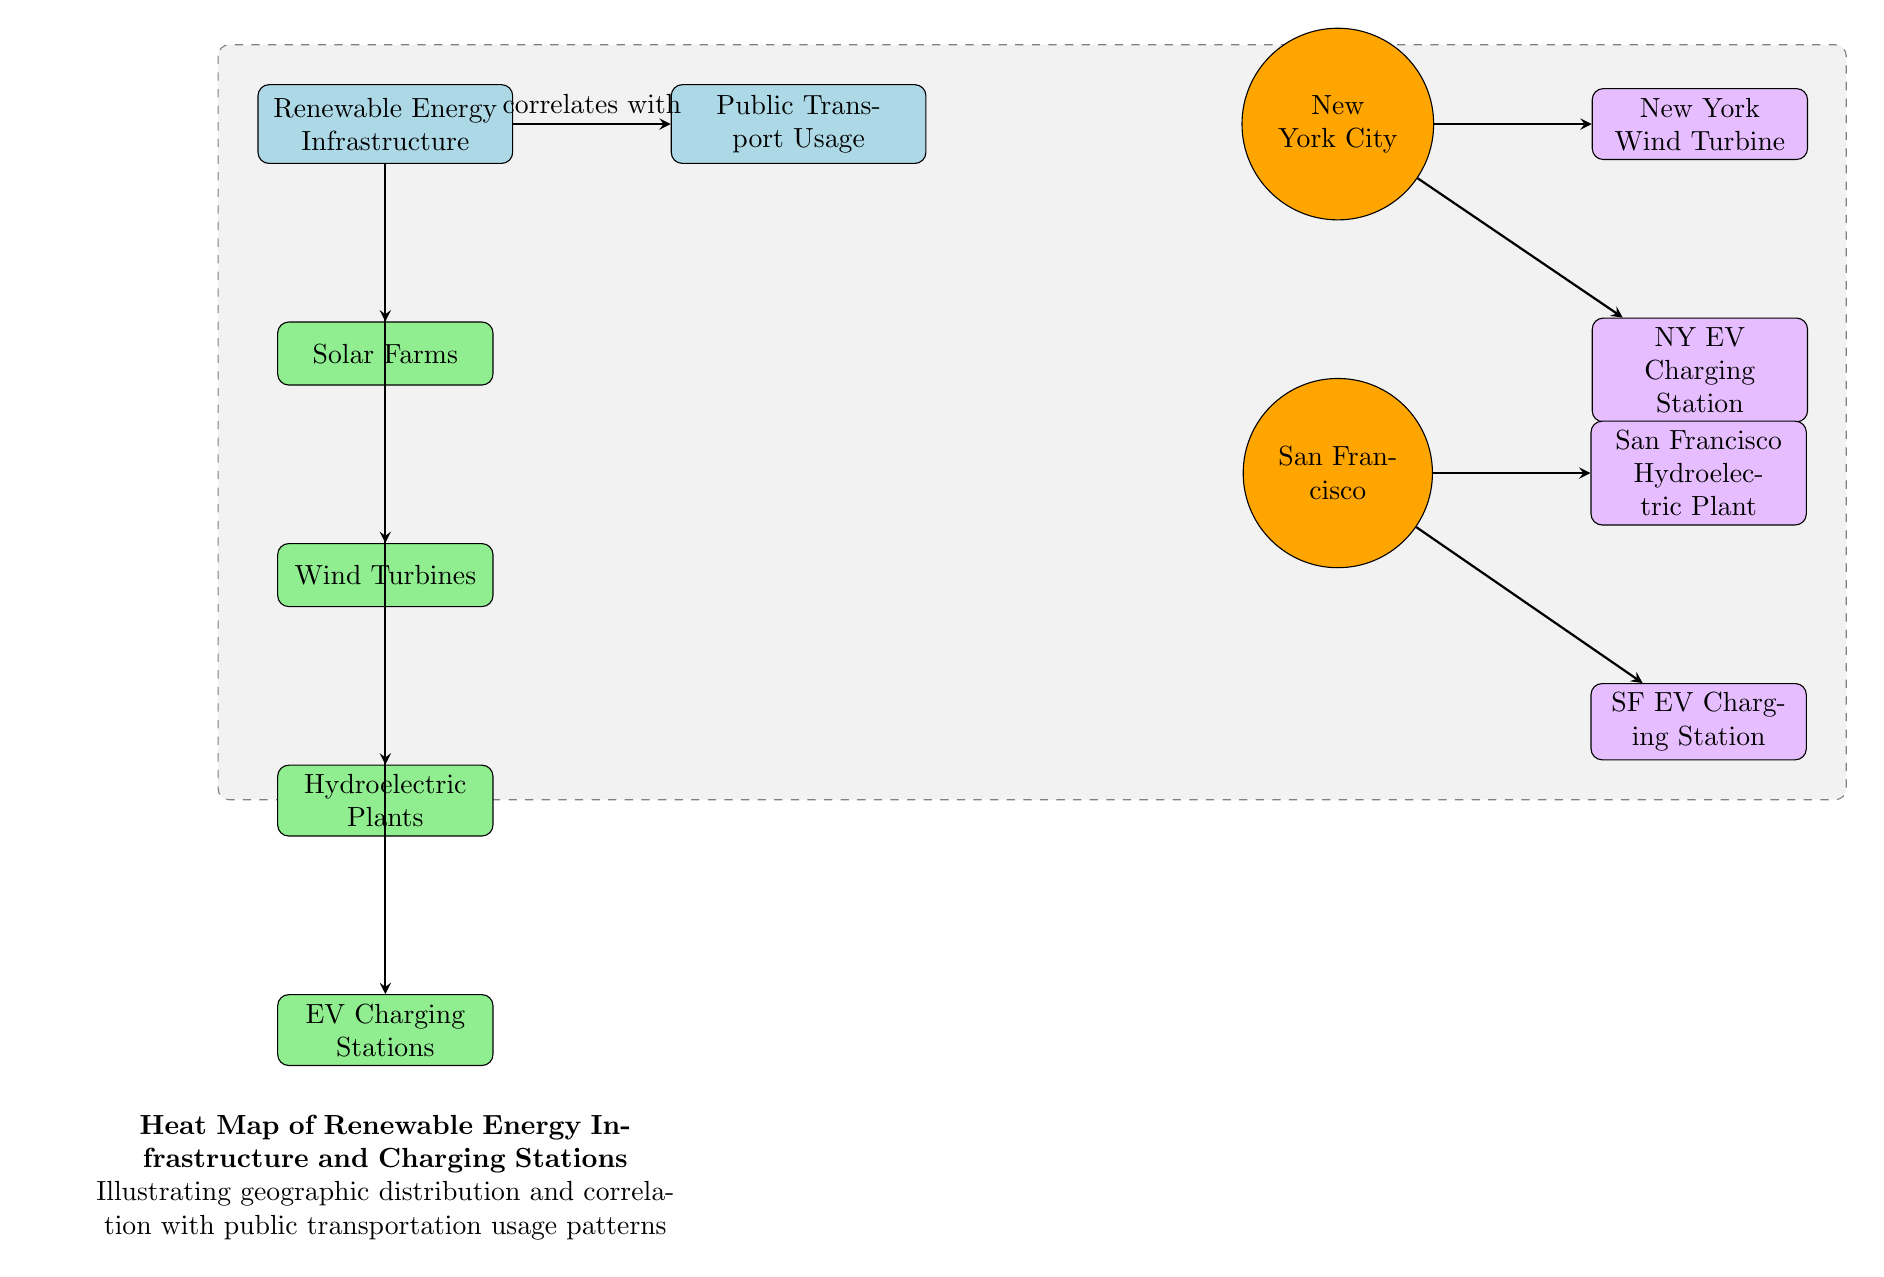What are the types of renewable energy infrastructure included in the diagram? The diagram displays the following renewable energy infrastructure types: Solar Farms, Wind Turbines, Hydroelectric Plants, and EV Charging Stations. This information is found in the subcategories below the "Renewable Energy Infrastructure" category in the diagram.
Answer: Solar Farms, Wind Turbines, Hydroelectric Plants, EV Charging Stations How many regions are represented in the diagram? The diagram features two regions: New York City and San Francisco. These regions are labeled as circular nodes and are placed to the right of the "Public Transport Usage" category. Counting these nodes gives the number of regions.
Answer: 2 Which infrastructure is associated with New York City? New York City is associated with two infrastructures: New York Wind Turbine and NY EV Charging Station. The arrows connecting these infrastructures to the New York City region indicate this direct association in the diagram.
Answer: New York Wind Turbine, NY EV Charging Station Which renewable energy infrastructure is located in San Francisco? In San Francisco, the infrastructure identified includes the San Francisco Hydroelectric Plant and SF EV Charging Station, illustrated by the direct arrows connecting these infrastructures to the San Francisco region in the diagram.
Answer: San Francisco Hydroelectric Plant, SF EV Charging Station What is the main correlation indicated in the diagram? The main correlation indicated in the diagram is that renewable energy infrastructure correlates with public transport usage. This relationship is represented by the arrow that directly connects the "Renewable Energy Infrastructure" category to the "Public Transport Usage" category.
Answer: Correlates with What is the color used for public transport usage in the diagram? The color used for the public transport usage category in the diagram is light blue. This can be confirmed by observing the fill color of the rectangular node labeled as "Public Transport Usage."
Answer: Light blue How many different types of renewable energy infrastructures are depicted in the diagram? The diagram shows four types of renewable energy infrastructures, as counted from the subcategories underneath the "Renewable Energy Infrastructure" node. Each type is represented as a separate rectangular node.
Answer: 4 Which city has an EV charging station according to the diagram? Both cities represented in the diagram, New York City and San Francisco, have EV charging stations. This is confirmed by the direct connections from each city region to their respective EV charging station nodes.
Answer: New York City, San Francisco What do the dashed rectangle in the background signify? The dashed rectangle in the background of the diagram highlights the area encompassing the "Renewable Energy Infrastructure" and the "Public Transport Usage" categories, indicating the focus of the heat map and correlational data depicted in that section.
Answer: Focus area of the heat map 